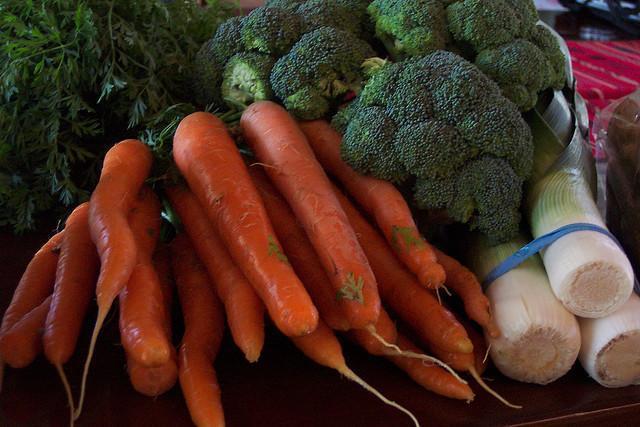How many broccolis are there?
Give a very brief answer. 7. 